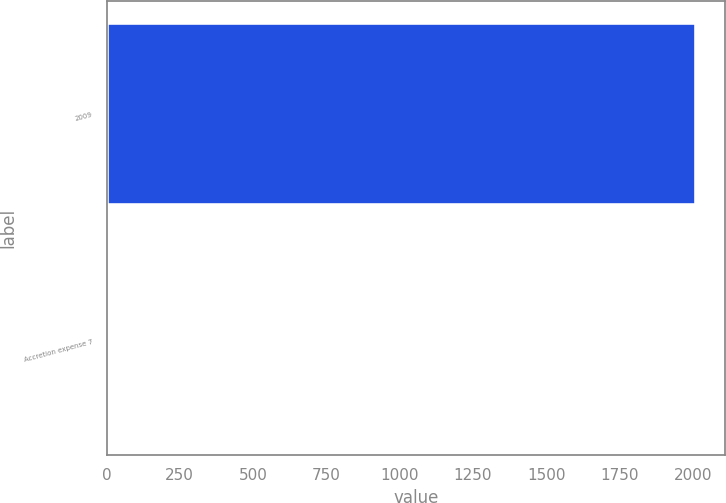Convert chart to OTSL. <chart><loc_0><loc_0><loc_500><loc_500><bar_chart><fcel>2009<fcel>Accretion expense 7<nl><fcel>2010<fcel>5<nl></chart> 